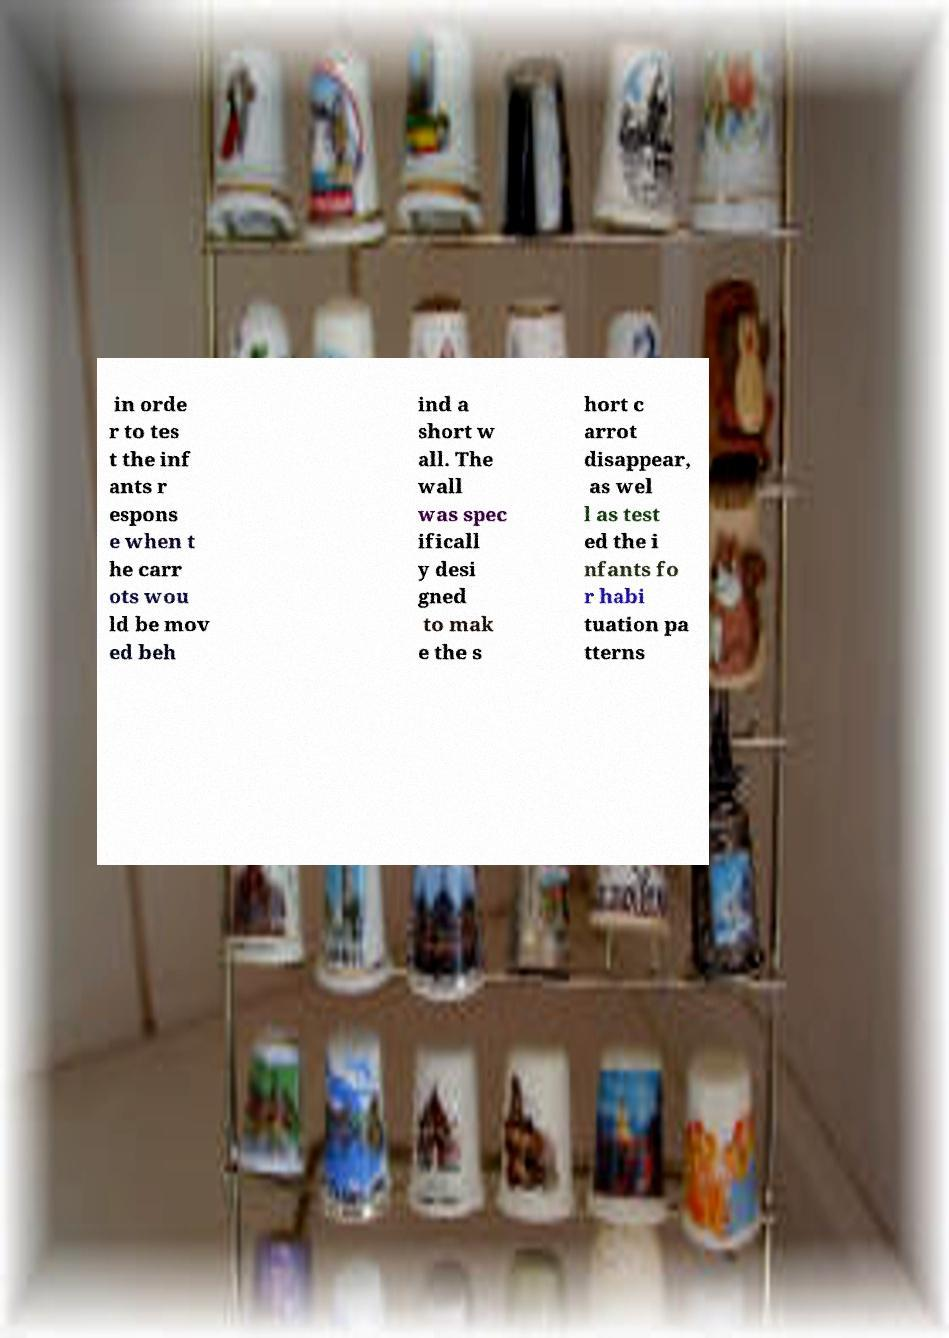For documentation purposes, I need the text within this image transcribed. Could you provide that? in orde r to tes t the inf ants r espons e when t he carr ots wou ld be mov ed beh ind a short w all. The wall was spec ificall y desi gned to mak e the s hort c arrot disappear, as wel l as test ed the i nfants fo r habi tuation pa tterns 